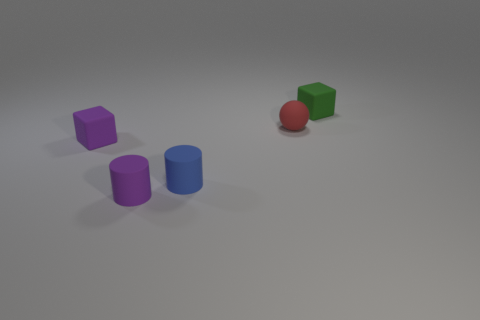How many tiny red objects are the same shape as the small green object?
Keep it short and to the point. 0. Are there any small yellow cylinders that have the same material as the red thing?
Make the answer very short. No. Are there fewer tiny rubber spheres to the right of the rubber ball than cyan metal spheres?
Your answer should be compact. No. There is a tiny matte thing that is behind the purple cylinder and in front of the purple cube; what is its shape?
Give a very brief answer. Cylinder. What number of objects are either matte objects behind the small purple matte block or rubber cubes?
Keep it short and to the point. 3. What number of things are either small red matte spheres or rubber objects in front of the tiny blue rubber cylinder?
Make the answer very short. 2. Do the purple thing in front of the small purple rubber block and the blue object have the same shape?
Make the answer very short. Yes. What number of small green matte cubes are on the left side of the tiny block that is in front of the cube to the right of the purple rubber block?
Your response must be concise. 0. Is there any other thing that is the same shape as the red matte object?
Offer a terse response. No. How many things are either small matte spheres or large cyan matte cylinders?
Your answer should be very brief. 1. 